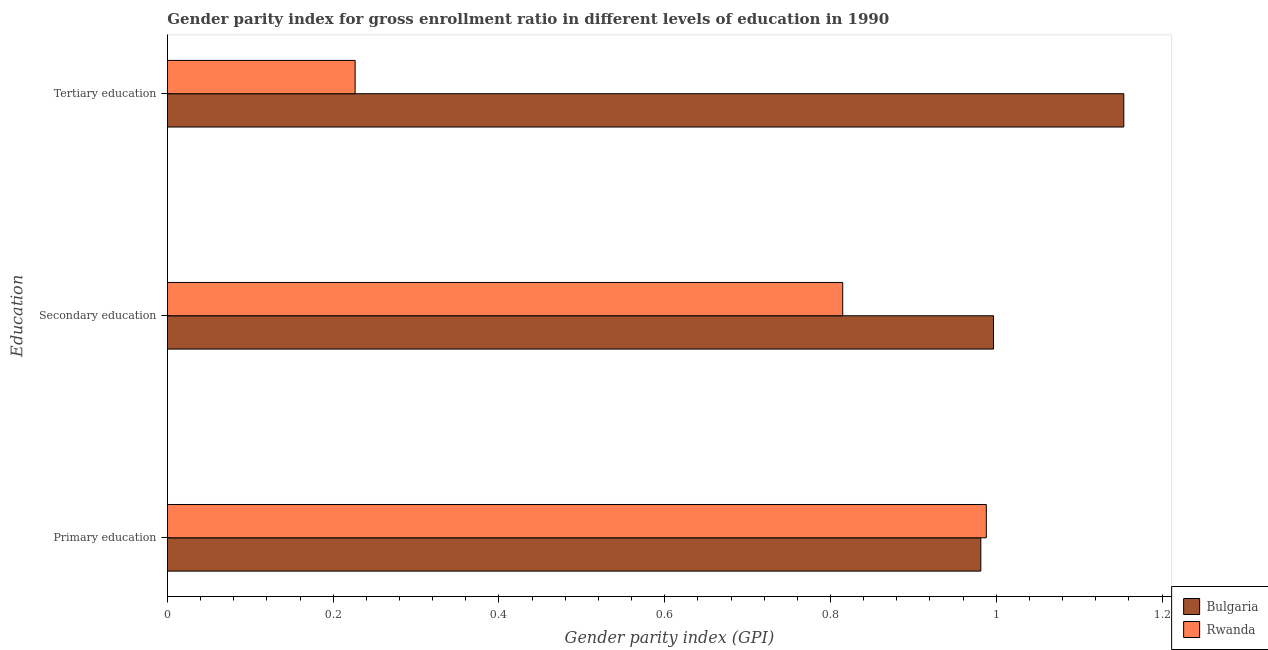How many different coloured bars are there?
Your response must be concise. 2. What is the label of the 1st group of bars from the top?
Offer a very short reply. Tertiary education. What is the gender parity index in tertiary education in Bulgaria?
Your answer should be compact. 1.15. Across all countries, what is the maximum gender parity index in tertiary education?
Your response must be concise. 1.15. Across all countries, what is the minimum gender parity index in primary education?
Make the answer very short. 0.98. In which country was the gender parity index in secondary education maximum?
Keep it short and to the point. Bulgaria. In which country was the gender parity index in tertiary education minimum?
Your response must be concise. Rwanda. What is the total gender parity index in secondary education in the graph?
Offer a terse response. 1.81. What is the difference between the gender parity index in tertiary education in Rwanda and that in Bulgaria?
Your answer should be very brief. -0.93. What is the difference between the gender parity index in secondary education in Bulgaria and the gender parity index in primary education in Rwanda?
Your answer should be compact. 0.01. What is the average gender parity index in secondary education per country?
Offer a very short reply. 0.91. What is the difference between the gender parity index in secondary education and gender parity index in primary education in Bulgaria?
Ensure brevity in your answer.  0.02. What is the ratio of the gender parity index in primary education in Bulgaria to that in Rwanda?
Provide a short and direct response. 0.99. Is the gender parity index in secondary education in Bulgaria less than that in Rwanda?
Offer a terse response. No. What is the difference between the highest and the second highest gender parity index in primary education?
Your answer should be compact. 0.01. What is the difference between the highest and the lowest gender parity index in secondary education?
Provide a succinct answer. 0.18. Is the sum of the gender parity index in tertiary education in Bulgaria and Rwanda greater than the maximum gender parity index in primary education across all countries?
Make the answer very short. Yes. What does the 1st bar from the top in Tertiary education represents?
Give a very brief answer. Rwanda. What does the 2nd bar from the bottom in Tertiary education represents?
Offer a terse response. Rwanda. Is it the case that in every country, the sum of the gender parity index in primary education and gender parity index in secondary education is greater than the gender parity index in tertiary education?
Keep it short and to the point. Yes. Are the values on the major ticks of X-axis written in scientific E-notation?
Ensure brevity in your answer.  No. Does the graph contain any zero values?
Make the answer very short. No. Does the graph contain grids?
Keep it short and to the point. No. How many legend labels are there?
Provide a succinct answer. 2. What is the title of the graph?
Offer a terse response. Gender parity index for gross enrollment ratio in different levels of education in 1990. Does "Malta" appear as one of the legend labels in the graph?
Offer a terse response. No. What is the label or title of the X-axis?
Offer a terse response. Gender parity index (GPI). What is the label or title of the Y-axis?
Offer a very short reply. Education. What is the Gender parity index (GPI) of Bulgaria in Primary education?
Provide a succinct answer. 0.98. What is the Gender parity index (GPI) in Rwanda in Primary education?
Your answer should be compact. 0.99. What is the Gender parity index (GPI) in Bulgaria in Secondary education?
Provide a succinct answer. 1. What is the Gender parity index (GPI) in Rwanda in Secondary education?
Your answer should be very brief. 0.81. What is the Gender parity index (GPI) in Bulgaria in Tertiary education?
Your response must be concise. 1.15. What is the Gender parity index (GPI) in Rwanda in Tertiary education?
Provide a succinct answer. 0.23. Across all Education, what is the maximum Gender parity index (GPI) of Bulgaria?
Your answer should be very brief. 1.15. Across all Education, what is the maximum Gender parity index (GPI) in Rwanda?
Your answer should be very brief. 0.99. Across all Education, what is the minimum Gender parity index (GPI) in Bulgaria?
Your response must be concise. 0.98. Across all Education, what is the minimum Gender parity index (GPI) of Rwanda?
Keep it short and to the point. 0.23. What is the total Gender parity index (GPI) of Bulgaria in the graph?
Your answer should be compact. 3.13. What is the total Gender parity index (GPI) in Rwanda in the graph?
Provide a succinct answer. 2.03. What is the difference between the Gender parity index (GPI) of Bulgaria in Primary education and that in Secondary education?
Ensure brevity in your answer.  -0.02. What is the difference between the Gender parity index (GPI) of Rwanda in Primary education and that in Secondary education?
Your answer should be very brief. 0.17. What is the difference between the Gender parity index (GPI) of Bulgaria in Primary education and that in Tertiary education?
Give a very brief answer. -0.17. What is the difference between the Gender parity index (GPI) in Rwanda in Primary education and that in Tertiary education?
Ensure brevity in your answer.  0.76. What is the difference between the Gender parity index (GPI) in Bulgaria in Secondary education and that in Tertiary education?
Provide a succinct answer. -0.16. What is the difference between the Gender parity index (GPI) of Rwanda in Secondary education and that in Tertiary education?
Provide a short and direct response. 0.59. What is the difference between the Gender parity index (GPI) in Bulgaria in Primary education and the Gender parity index (GPI) in Rwanda in Secondary education?
Your response must be concise. 0.17. What is the difference between the Gender parity index (GPI) of Bulgaria in Primary education and the Gender parity index (GPI) of Rwanda in Tertiary education?
Your answer should be very brief. 0.75. What is the difference between the Gender parity index (GPI) of Bulgaria in Secondary education and the Gender parity index (GPI) of Rwanda in Tertiary education?
Offer a very short reply. 0.77. What is the average Gender parity index (GPI) in Bulgaria per Education?
Give a very brief answer. 1.04. What is the average Gender parity index (GPI) in Rwanda per Education?
Ensure brevity in your answer.  0.68. What is the difference between the Gender parity index (GPI) of Bulgaria and Gender parity index (GPI) of Rwanda in Primary education?
Give a very brief answer. -0.01. What is the difference between the Gender parity index (GPI) in Bulgaria and Gender parity index (GPI) in Rwanda in Secondary education?
Your answer should be very brief. 0.18. What is the difference between the Gender parity index (GPI) of Bulgaria and Gender parity index (GPI) of Rwanda in Tertiary education?
Offer a terse response. 0.93. What is the ratio of the Gender parity index (GPI) of Bulgaria in Primary education to that in Secondary education?
Your response must be concise. 0.98. What is the ratio of the Gender parity index (GPI) in Rwanda in Primary education to that in Secondary education?
Give a very brief answer. 1.21. What is the ratio of the Gender parity index (GPI) in Bulgaria in Primary education to that in Tertiary education?
Make the answer very short. 0.85. What is the ratio of the Gender parity index (GPI) of Rwanda in Primary education to that in Tertiary education?
Your response must be concise. 4.36. What is the ratio of the Gender parity index (GPI) of Bulgaria in Secondary education to that in Tertiary education?
Ensure brevity in your answer.  0.86. What is the ratio of the Gender parity index (GPI) of Rwanda in Secondary education to that in Tertiary education?
Make the answer very short. 3.6. What is the difference between the highest and the second highest Gender parity index (GPI) in Bulgaria?
Ensure brevity in your answer.  0.16. What is the difference between the highest and the second highest Gender parity index (GPI) in Rwanda?
Provide a succinct answer. 0.17. What is the difference between the highest and the lowest Gender parity index (GPI) in Bulgaria?
Ensure brevity in your answer.  0.17. What is the difference between the highest and the lowest Gender parity index (GPI) of Rwanda?
Your answer should be compact. 0.76. 